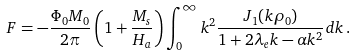Convert formula to latex. <formula><loc_0><loc_0><loc_500><loc_500>F = - \frac { \Phi _ { 0 } M _ { 0 } } { 2 \pi } \left ( 1 + \frac { M _ { s } } { H _ { a } } \right ) \int _ { 0 } ^ { \infty } k ^ { 2 } \frac { J _ { 1 } ( k \rho _ { 0 } ) } { 1 + 2 \lambda _ { e } k - \alpha k ^ { 2 } } d k \, .</formula> 